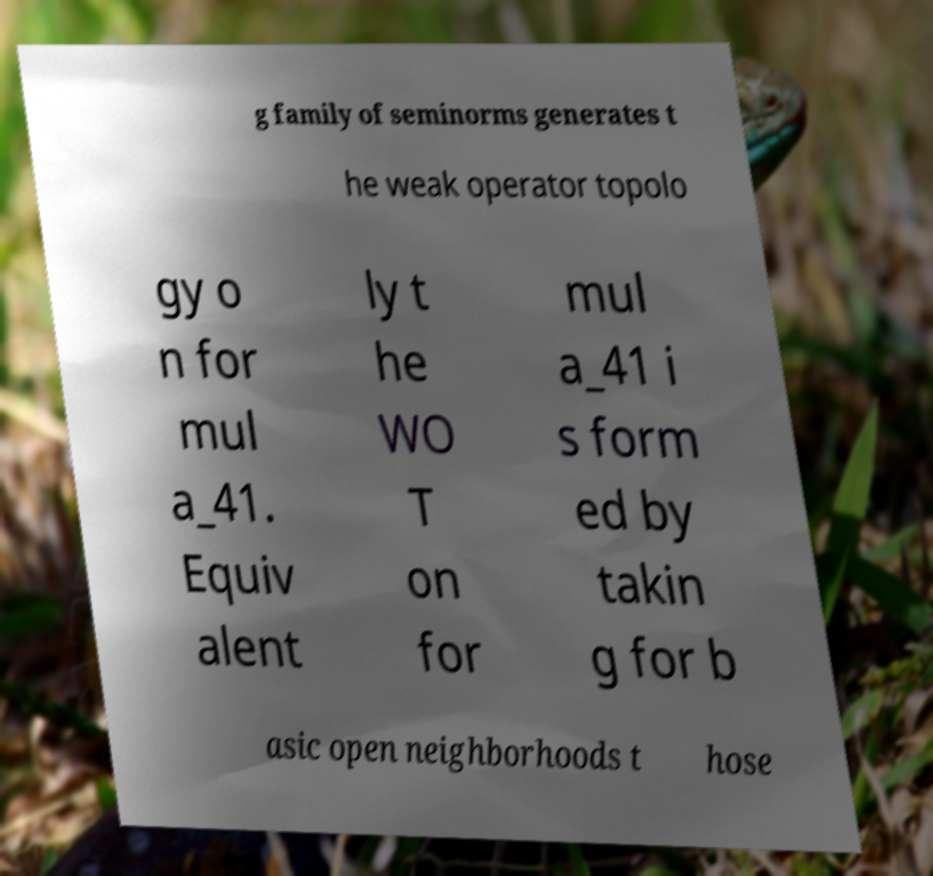I need the written content from this picture converted into text. Can you do that? g family of seminorms generates t he weak operator topolo gy o n for mul a_41. Equiv alent ly t he WO T on for mul a_41 i s form ed by takin g for b asic open neighborhoods t hose 